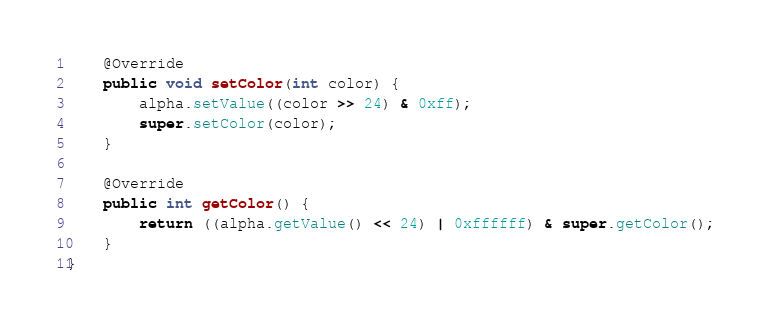<code> <loc_0><loc_0><loc_500><loc_500><_Java_>    @Override
    public void setColor(int color) {
        alpha.setValue((color >> 24) & 0xff);
        super.setColor(color);
    }

    @Override
    public int getColor() {
        return ((alpha.getValue() << 24) | 0xffffff) & super.getColor();
    }
}
</code> 